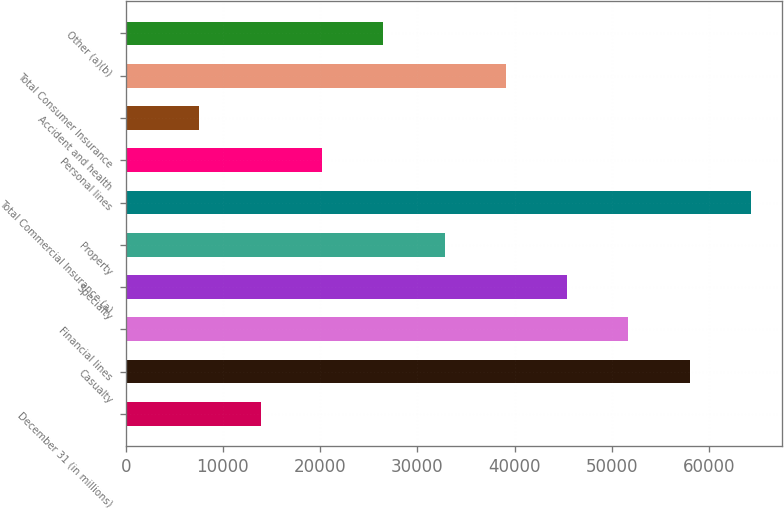Convert chart to OTSL. <chart><loc_0><loc_0><loc_500><loc_500><bar_chart><fcel>December 31 (in millions)<fcel>Casualty<fcel>Financial lines<fcel>Specialty<fcel>Property<fcel>Total Commercial Insurance (a)<fcel>Personal lines<fcel>Accident and health<fcel>Total Consumer Insurance<fcel>Other (a)(b)<nl><fcel>13892.8<fcel>58013.1<fcel>51710.2<fcel>45407.3<fcel>32801.5<fcel>64316<fcel>20195.7<fcel>7589.9<fcel>39104.4<fcel>26498.6<nl></chart> 